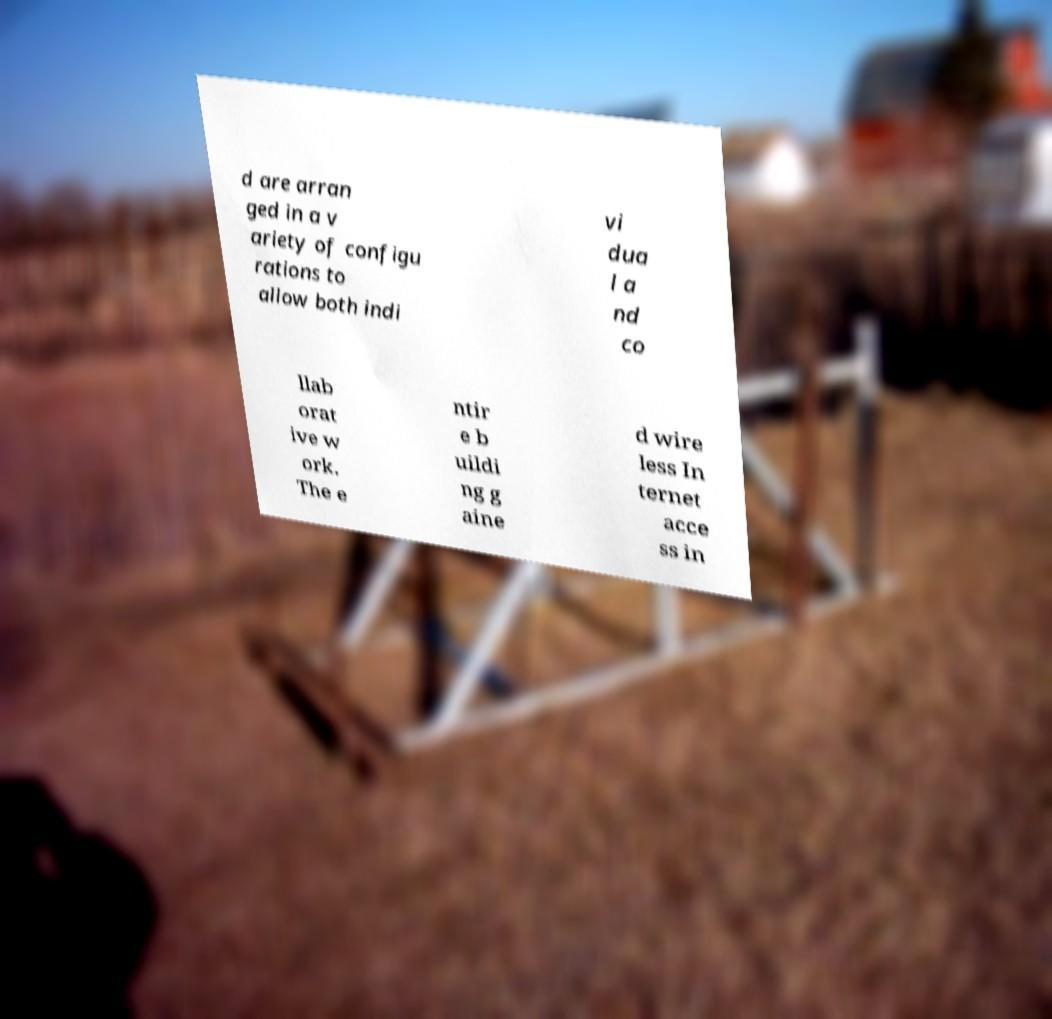Can you accurately transcribe the text from the provided image for me? d are arran ged in a v ariety of configu rations to allow both indi vi dua l a nd co llab orat ive w ork. The e ntir e b uildi ng g aine d wire less In ternet acce ss in 